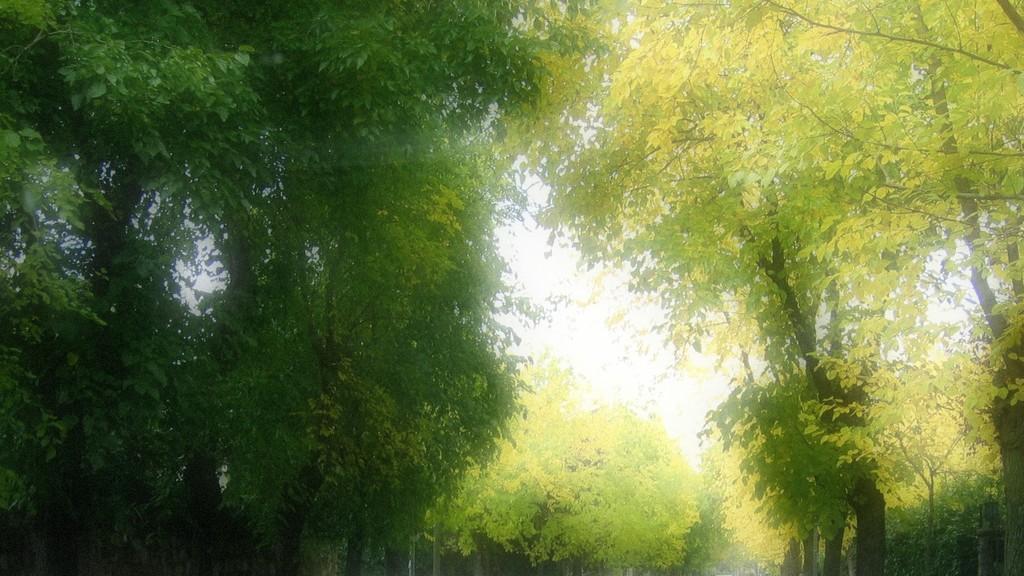In one or two sentences, can you explain what this image depicts? In this image, I can see the trees with branches and leaves. These leaves are green in color. 